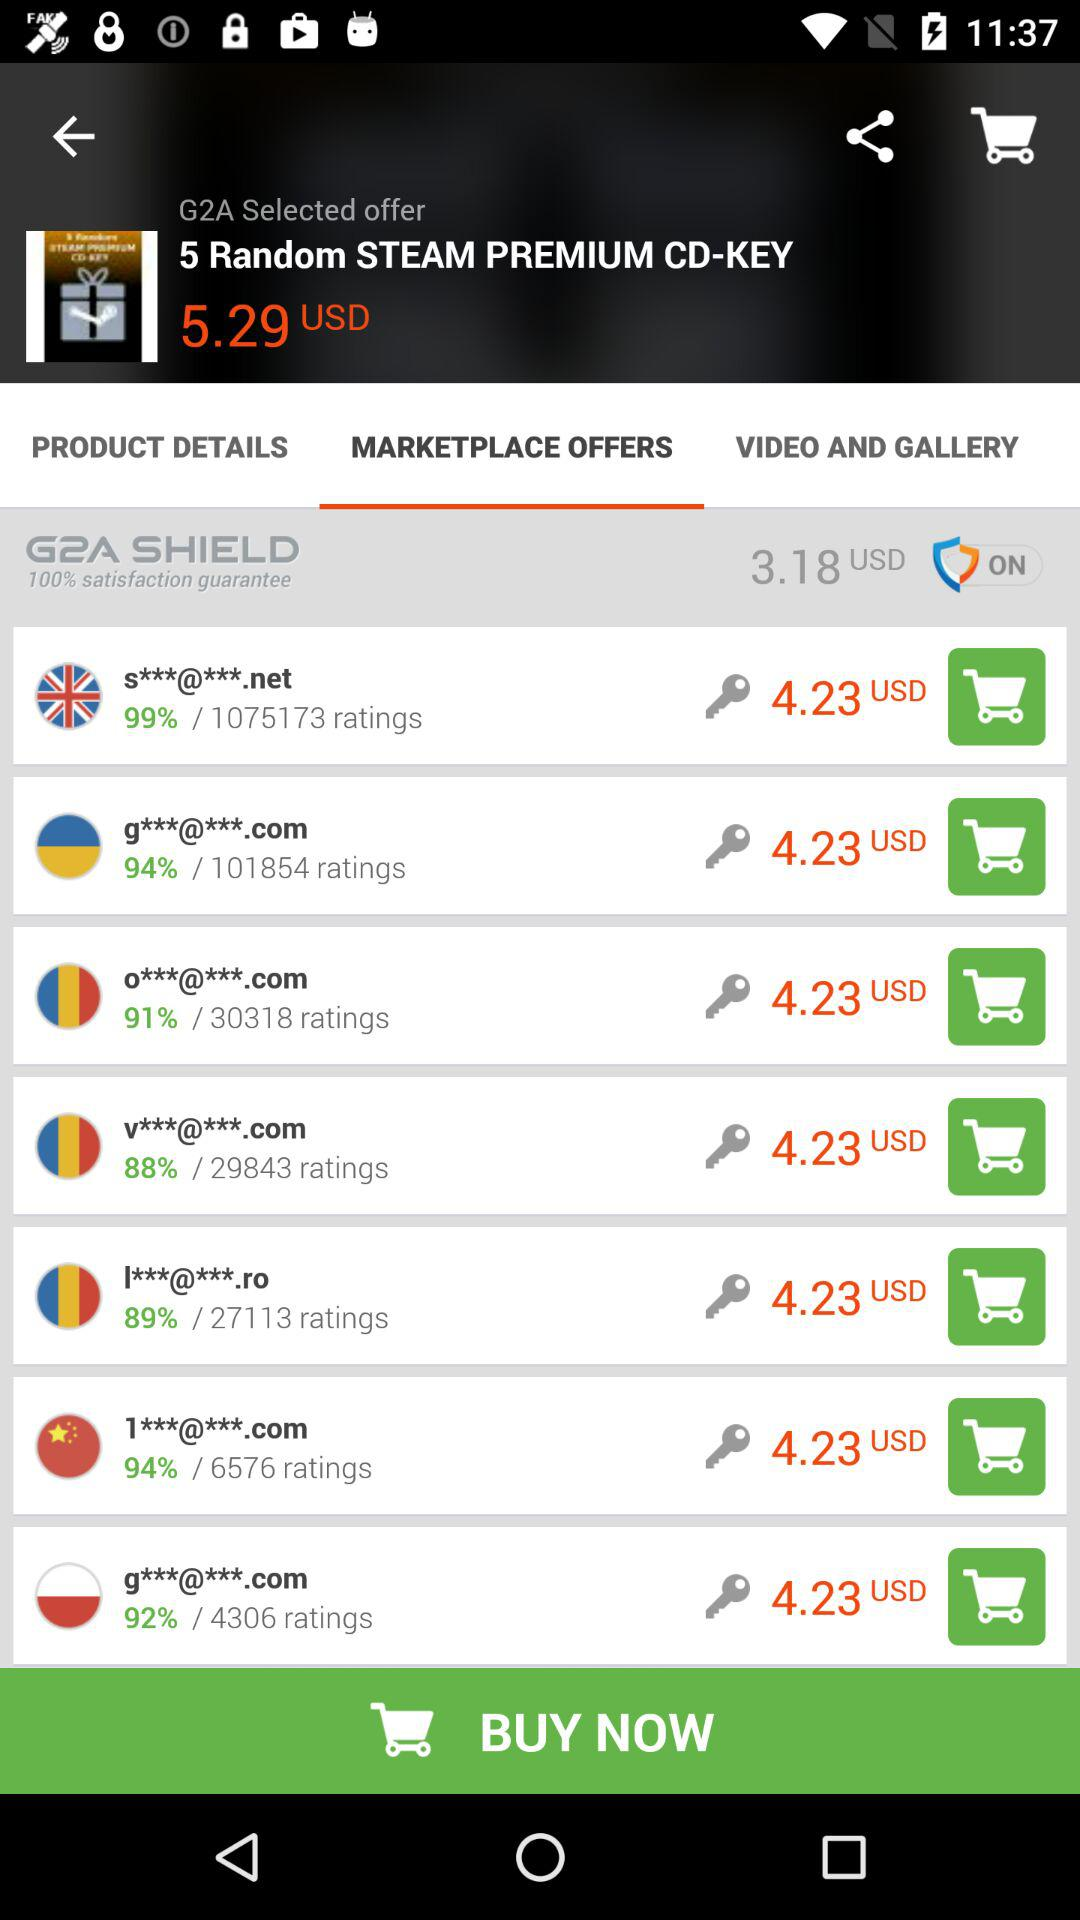What is the price of "5 Random STEAM PREMIUM CD-KEY"? The price of "5 Random STEAM PREMIUM CD-KEY" is 5.29 USD. 